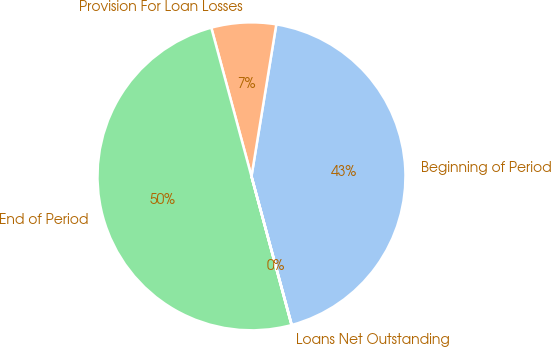Convert chart to OTSL. <chart><loc_0><loc_0><loc_500><loc_500><pie_chart><fcel>Beginning of Period<fcel>Provision For Loan Losses<fcel>End of Period<fcel>Loans Net Outstanding<nl><fcel>43.21%<fcel>6.78%<fcel>49.99%<fcel>0.02%<nl></chart> 